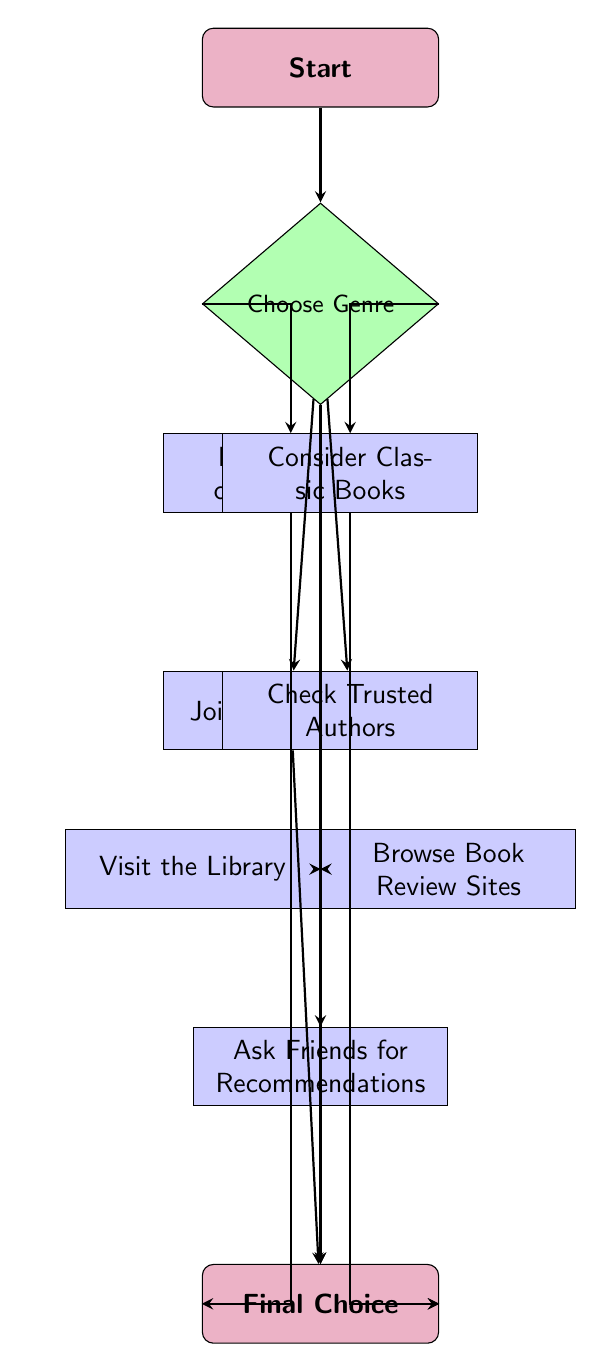What is the first step in the flowchart? The flowchart begins with the node labeled "Start," indicating that this is the entry point of the process.
Answer: Start How many genres can you choose from? The "Choose Genre" node lists five options: Fiction, Non-Fiction, Mystery, Science Fiction, and Fantasy. Thus, there are five genres you can choose from.
Answer: 5 What do you do if you choose "Fiction" or "Non-Fiction"? If you choose "Fiction" or "Non-Fiction," you have the option to either look for recent releases or consider classic books, as indicated in the flowchart.
Answer: Look for Recent Releases, Consider Classic Books Which node follows "Ask Friends for Recommendations"? According to the diagram, the node that follows "Ask Friends for Recommendations" is "Final Choice," which signifies the end of the decision-making process.
Answer: Final Choice What are the options available after choosing a genre? After choosing a genre, you can either look for recent releases, consider classic books, join a book club, check trusted authors, visit the library, browse book review sites, or ask friends for recommendations.
Answer: Recent Releases, Classic Books, Join a Book Club, Check Trusted Authors, Visit the Library, Browse Book Review Sites, Ask Friends for Recommendations If you choose "Non-Fiction," what processes can you directly pursue afterward? Choosing "Non-Fiction" allows you to either look for recent releases or consider classic books. It also enables participation in a book club, checking trusted authors, visiting the library, browsing book review sites, or asking friends for recommendations.
Answer: Look for Recent Releases, Consider Classic Books, Join a Book Club, Check Trusted Authors, Visit the Library, Browse Book Review Sites, Ask Friends for Recommendations Which process can you pursue by selecting "Fiction" or "Non-Fiction"? By selecting "Fiction" or "Non-Fiction," you can pursue both recent releases and classic books as valid processes following the genre decision.
Answer: Recent Releases, Classic Books What is the relationship between "Choose Genre" and "Final Choice"? The "Choose Genre" node leads to various processes that ultimately all connect to the "Final Choice" node, meaning that regardless of the path taken, it will conclude at the same endpoint.
Answer: Each path leads to Final Choice 